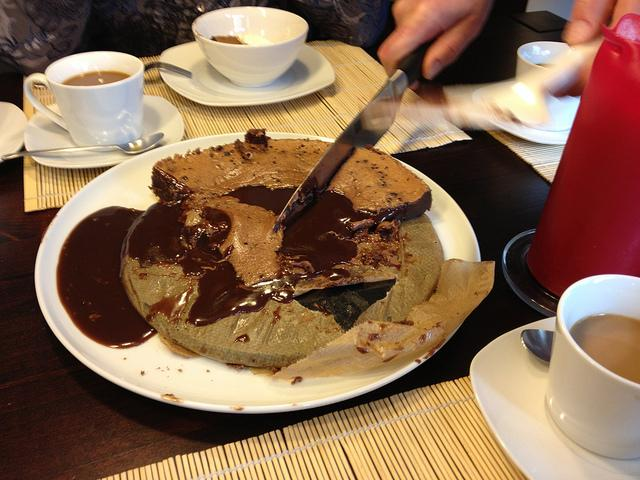What is being cut? dessert 